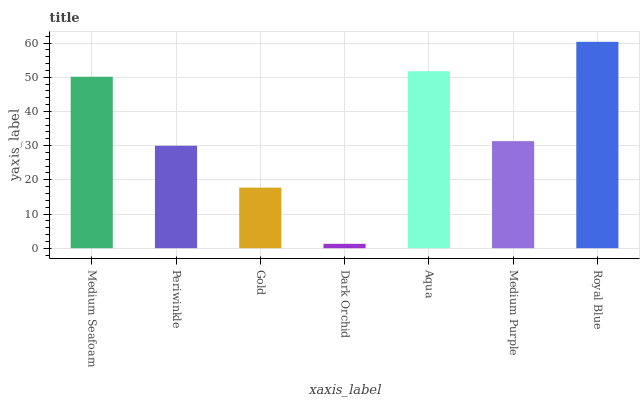Is Dark Orchid the minimum?
Answer yes or no. Yes. Is Royal Blue the maximum?
Answer yes or no. Yes. Is Periwinkle the minimum?
Answer yes or no. No. Is Periwinkle the maximum?
Answer yes or no. No. Is Medium Seafoam greater than Periwinkle?
Answer yes or no. Yes. Is Periwinkle less than Medium Seafoam?
Answer yes or no. Yes. Is Periwinkle greater than Medium Seafoam?
Answer yes or no. No. Is Medium Seafoam less than Periwinkle?
Answer yes or no. No. Is Medium Purple the high median?
Answer yes or no. Yes. Is Medium Purple the low median?
Answer yes or no. Yes. Is Royal Blue the high median?
Answer yes or no. No. Is Gold the low median?
Answer yes or no. No. 